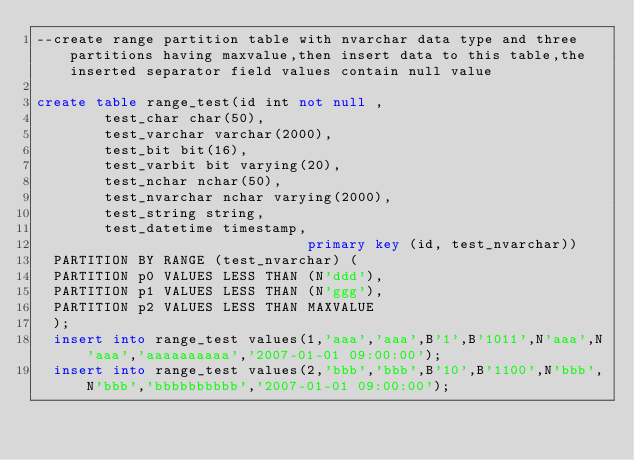Convert code to text. <code><loc_0><loc_0><loc_500><loc_500><_SQL_>--create range partition table with nvarchar data type and three partitions having maxvalue,then insert data to this table,the inserted separator field values contain null value

create table range_test(id int not null ,
				test_char char(50),
				test_varchar varchar(2000),
				test_bit bit(16),
				test_varbit bit varying(20),
				test_nchar nchar(50),
				test_nvarchar nchar varying(2000),
				test_string string,
				test_datetime timestamp,
                                primary key (id, test_nvarchar))
	PARTITION BY RANGE (test_nvarchar) (
	PARTITION p0 VALUES LESS THAN (N'ddd'),
	PARTITION p1 VALUES LESS THAN (N'ggg'),
	PARTITION p2 VALUES LESS THAN MAXVALUE
	);
	insert into range_test values(1,'aaa','aaa',B'1',B'1011',N'aaa',N'aaa','aaaaaaaaaa','2007-01-01 09:00:00');
	insert into range_test values(2,'bbb','bbb',B'10',B'1100',N'bbb',N'bbb','bbbbbbbbbb','2007-01-01 09:00:00');</code> 